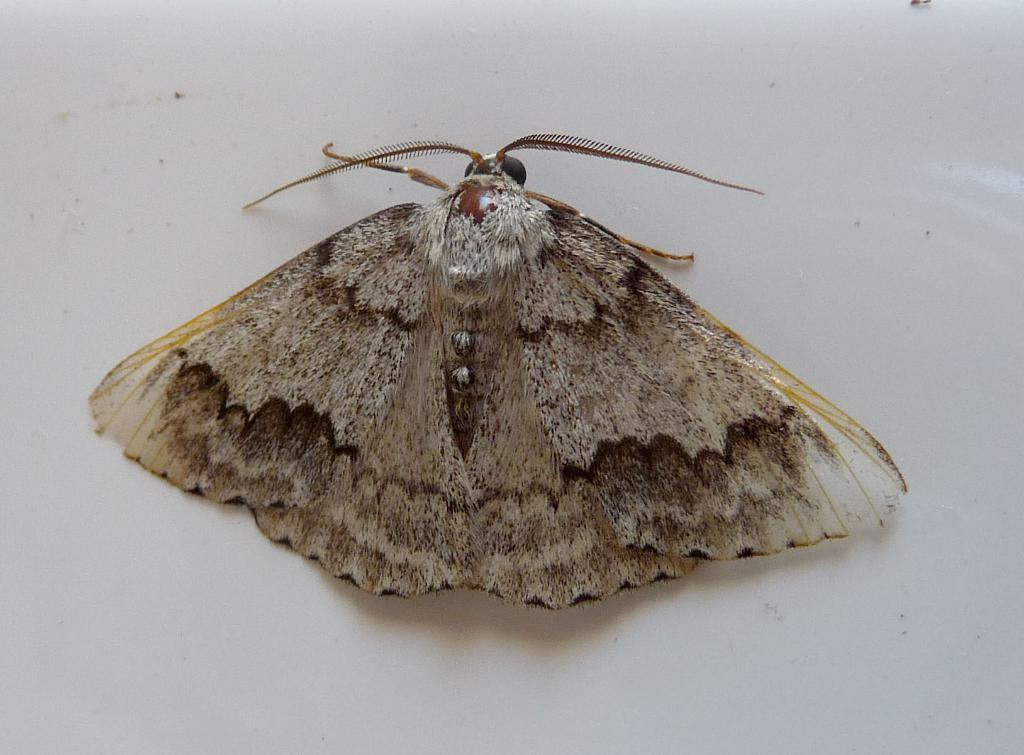What type of insect is in the image? There is a brown house moth in the image. What is the color of the surface the moth is on? The moth is on a white surface. What type of mask is the moth wearing in the image? There is no mask present in the image; it is a brown house moth on a white surface. 